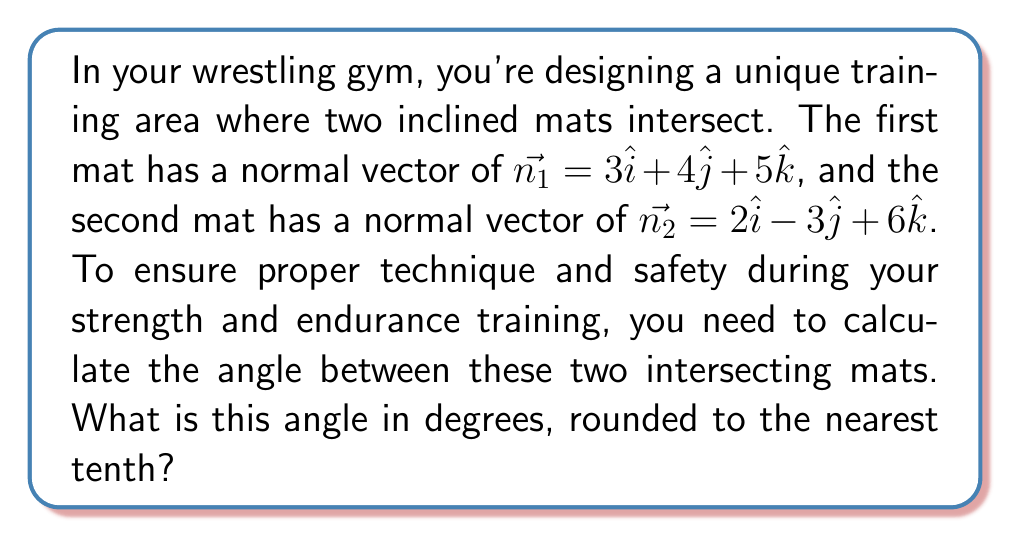Provide a solution to this math problem. To find the angle between two intersecting planes, we can use the dot product of their normal vectors. The formula for the angle $\theta$ between two planes is:

$$\cos \theta = \frac{|\vec{n_1} \cdot \vec{n_2}|}{|\vec{n_1}||\vec{n_2}|}$$

Let's solve this step by step:

1) First, calculate the dot product $\vec{n_1} \cdot \vec{n_2}$:
   $$\vec{n_1} \cdot \vec{n_2} = (3)(2) + (4)(-3) + (5)(6) = 6 - 12 + 30 = 24$$

2) Calculate the magnitudes of $\vec{n_1}$ and $\vec{n_2}$:
   $$|\vec{n_1}| = \sqrt{3^2 + 4^2 + 5^2} = \sqrt{9 + 16 + 25} = \sqrt{50}$$
   $$|\vec{n_2}| = \sqrt{2^2 + (-3)^2 + 6^2} = \sqrt{4 + 9 + 36} = \sqrt{49} = 7$$

3) Now, substitute these values into the formula:
   $$\cos \theta = \frac{|24|}{\sqrt{50} \cdot 7} = \frac{24}{\sqrt{50} \cdot 7}$$

4) Calculate this value:
   $$\cos \theta \approx 0.4855$$

5) To find $\theta$, take the inverse cosine (arccos) of both sides:
   $$\theta = \arccos(0.4855)$$

6) Convert to degrees and round to the nearest tenth:
   $$\theta \approx 60.9°$$
Answer: The angle between the two intersecting mats is approximately 60.9°. 